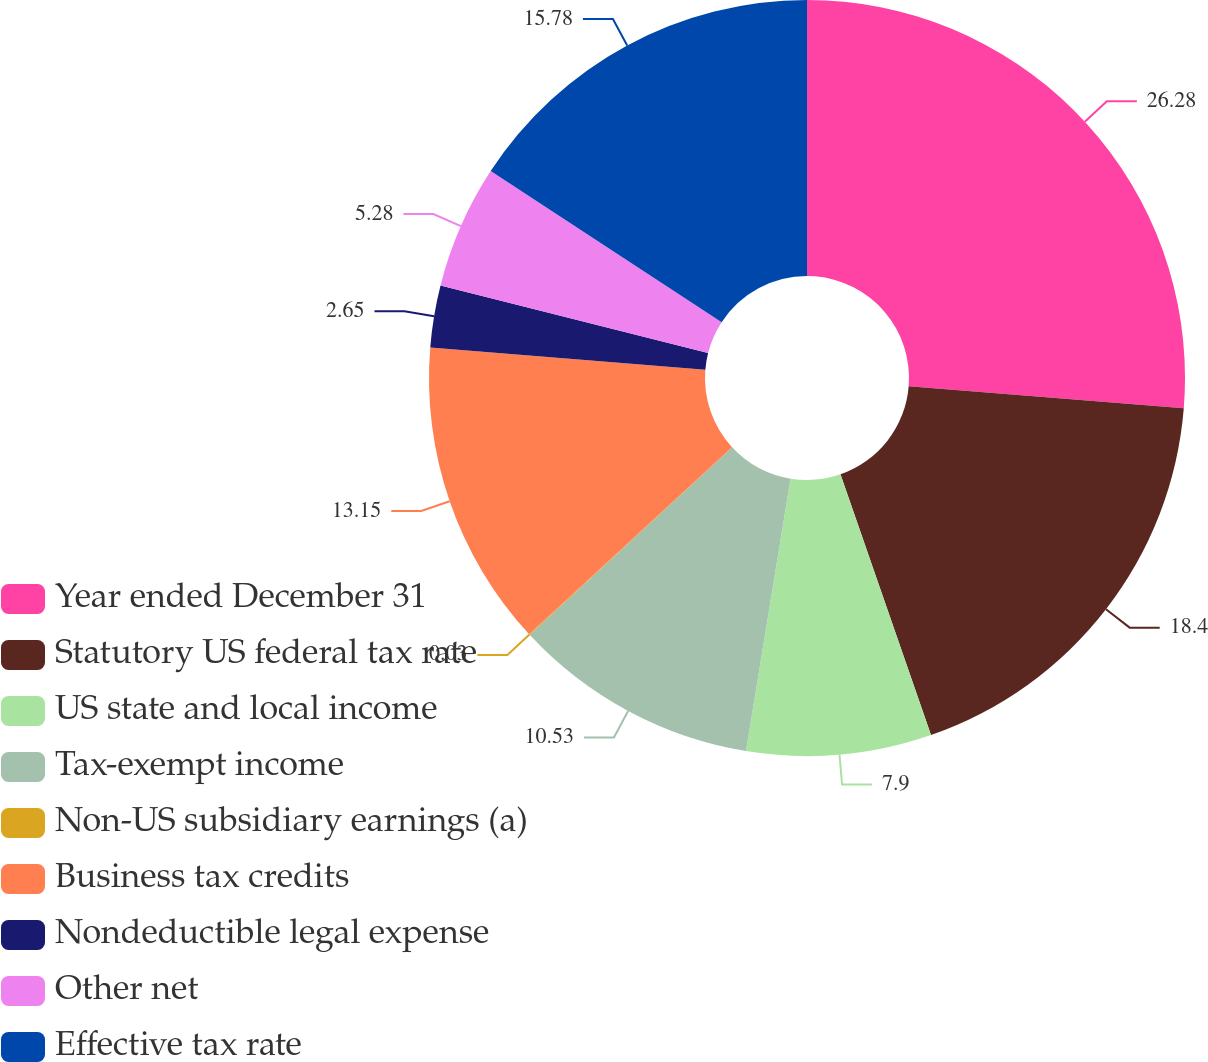Convert chart. <chart><loc_0><loc_0><loc_500><loc_500><pie_chart><fcel>Year ended December 31<fcel>Statutory US federal tax rate<fcel>US state and local income<fcel>Tax-exempt income<fcel>Non-US subsidiary earnings (a)<fcel>Business tax credits<fcel>Nondeductible legal expense<fcel>Other net<fcel>Effective tax rate<nl><fcel>26.28%<fcel>18.4%<fcel>7.9%<fcel>10.53%<fcel>0.03%<fcel>13.15%<fcel>2.65%<fcel>5.28%<fcel>15.78%<nl></chart> 